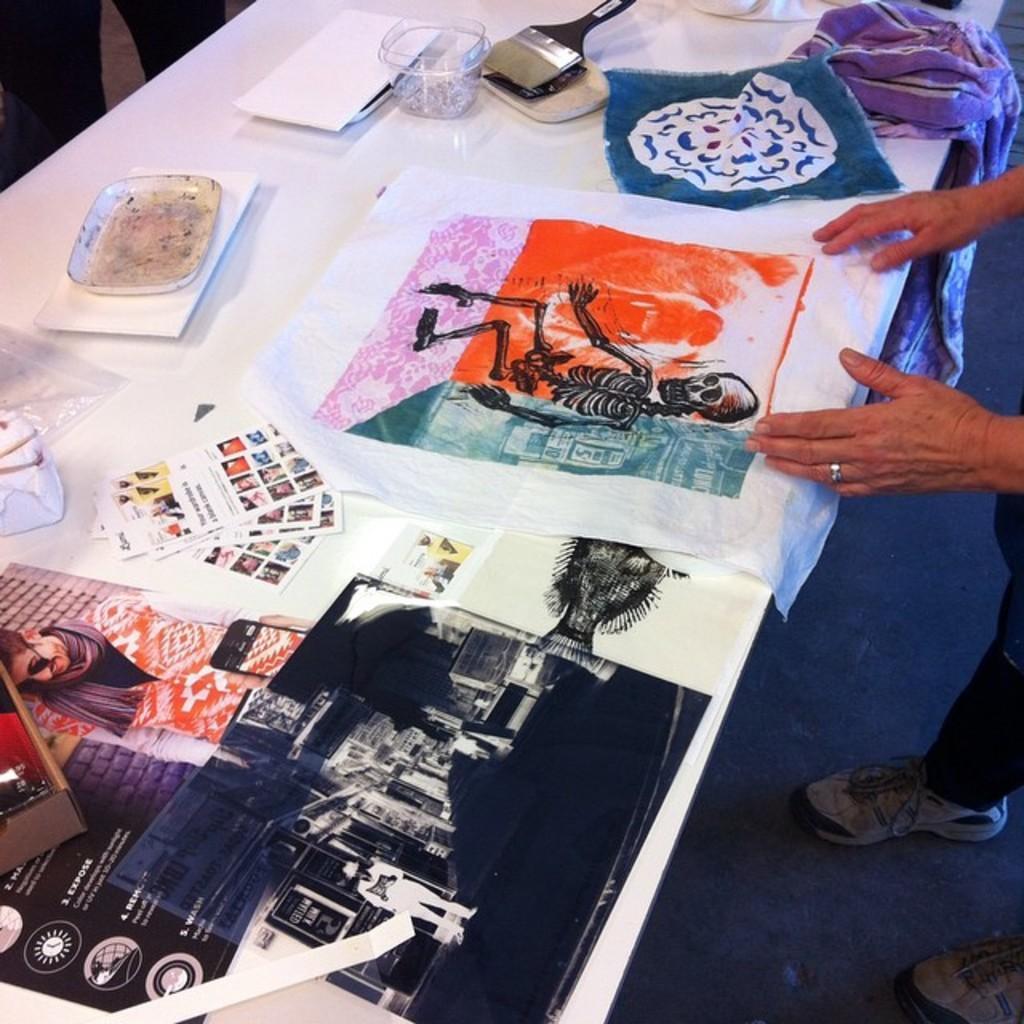Could you give a brief overview of what you see in this image? In the image we can see a person standing, wearing clothes, finger ring and shoes. Here we can see the table, on the table, we can see posters, containers, cloth and the paint brush. 